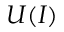Convert formula to latex. <formula><loc_0><loc_0><loc_500><loc_500>U ( I )</formula> 